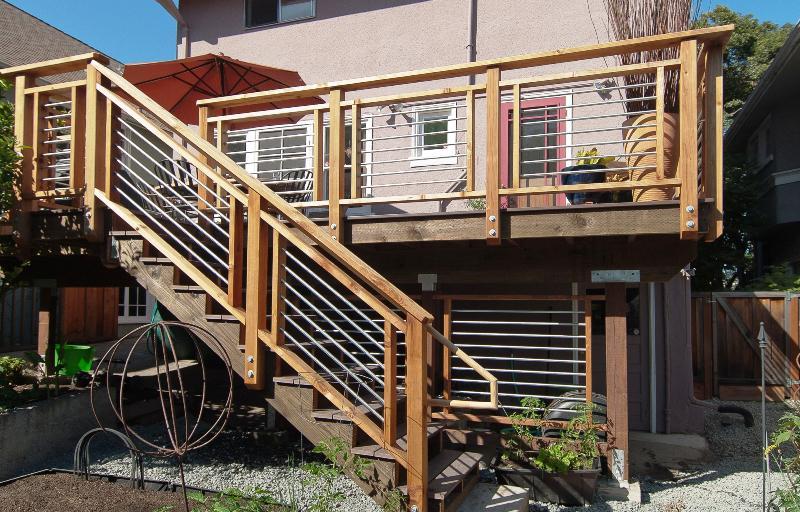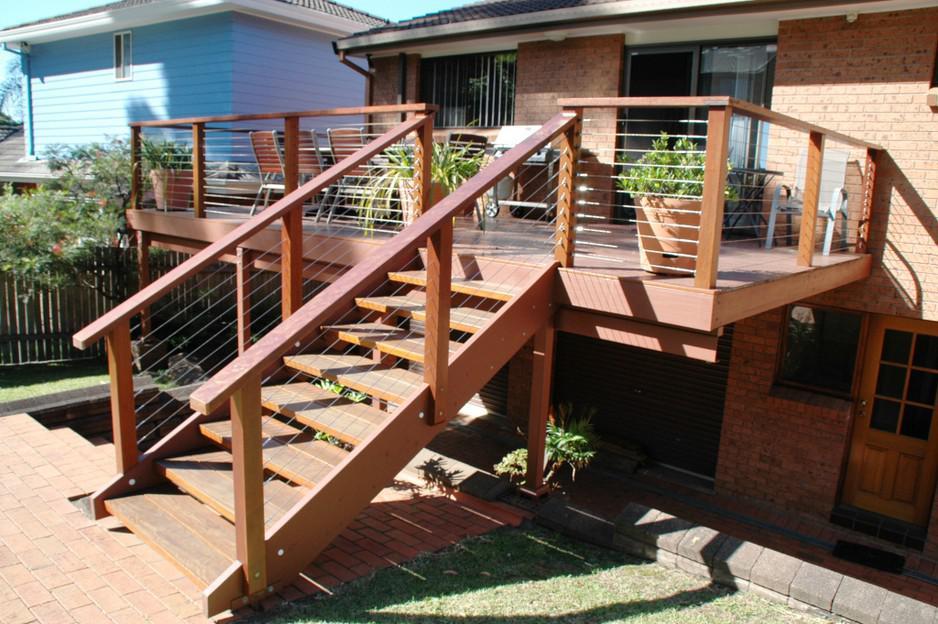The first image is the image on the left, the second image is the image on the right. Examine the images to the left and right. Is the description "In at least one image there a is wooden and metal string balcony overlooking the water and trees." accurate? Answer yes or no. No. The first image is the image on the left, the second image is the image on the right. Analyze the images presented: Is the assertion "The left image shows the corner of a deck with a silver-colored pipe-shaped handrail and thin horizontal metal rods beween upright metal posts." valid? Answer yes or no. No. 